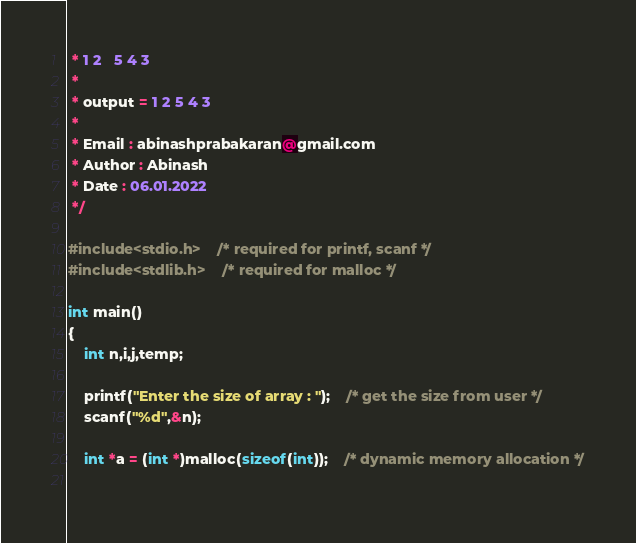Convert code to text. <code><loc_0><loc_0><loc_500><loc_500><_C_> * 1 2   5 4 3
 * 
 * output = 1 2 5 4 3
 *
 * Email : abinashprabakaran@gmail.com
 * Author : Abinash
 * Date : 06.01.2022
 */

#include<stdio.h>	/* required for printf, scanf */
#include<stdlib.h>	/* required for malloc */

int main()
{
	int n,i,j,temp;

	printf("Enter the size of array : ");	/* get the size from user */
	scanf("%d",&n);

	int *a = (int *)malloc(sizeof(int));	/* dynamic memory allocation */
	</code> 